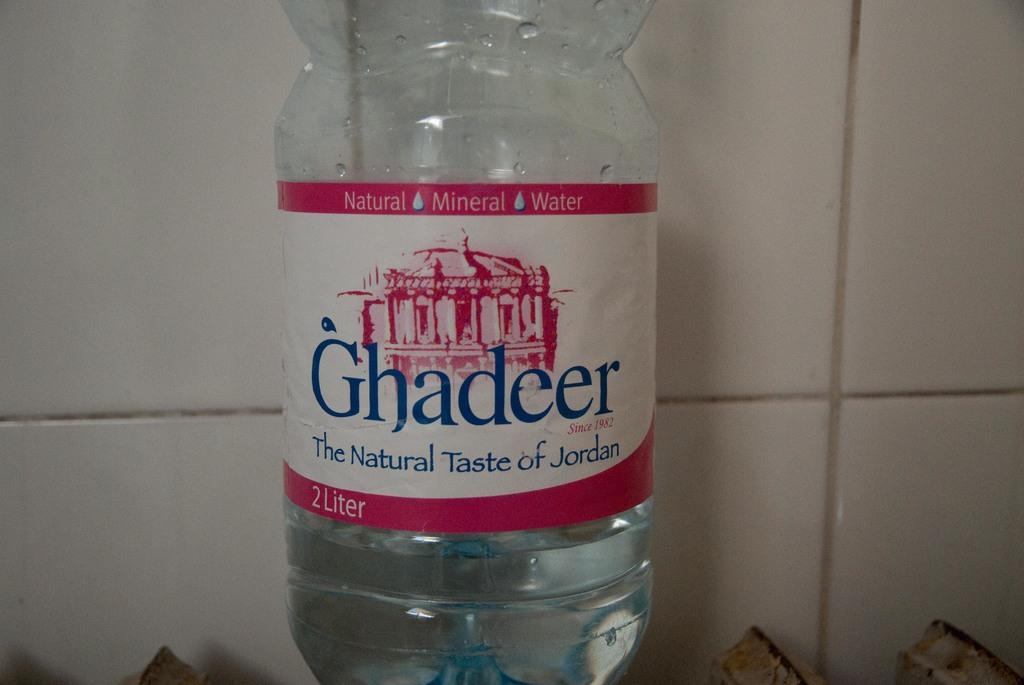Provide a one-sentence caption for the provided image. A waterbottle claims to have The Natural Taste of Jordan. 